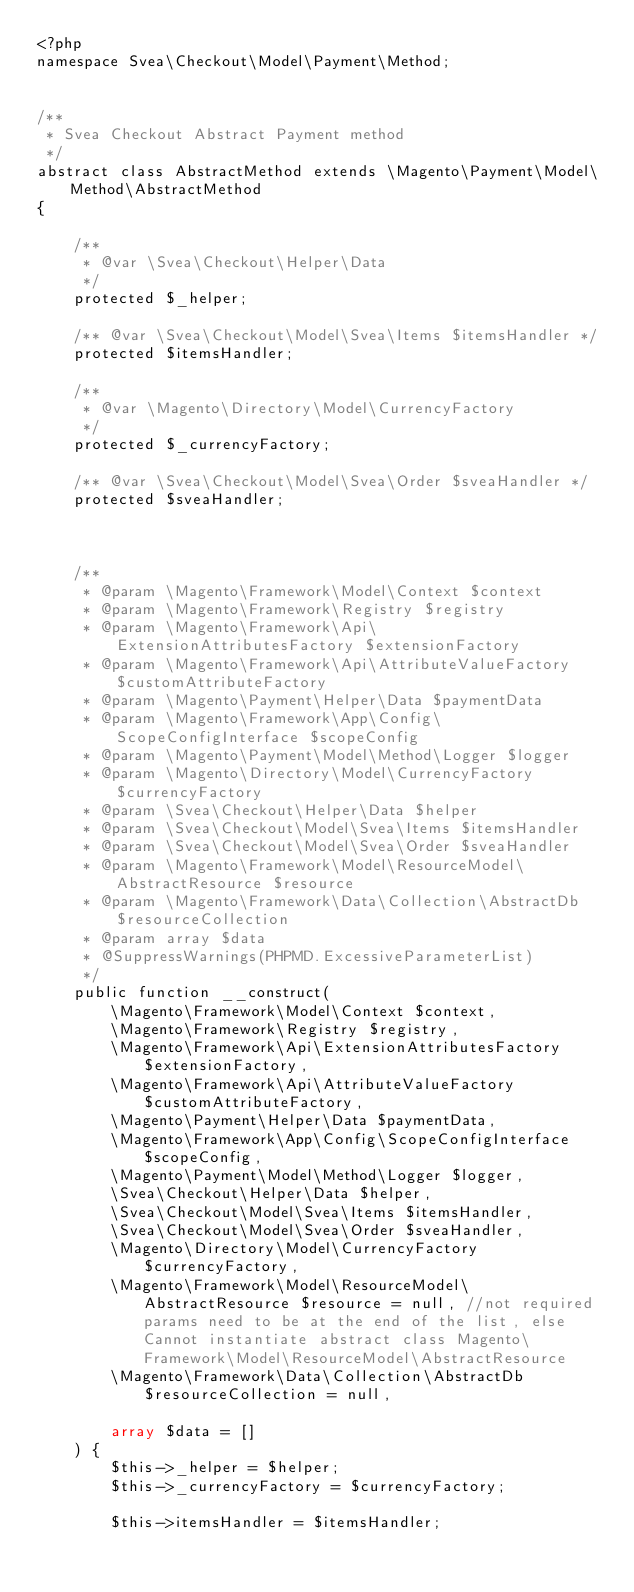Convert code to text. <code><loc_0><loc_0><loc_500><loc_500><_PHP_><?php
namespace Svea\Checkout\Model\Payment\Method;


/**
 * Svea Checkout Abstract Payment method
 */
abstract class AbstractMethod extends \Magento\Payment\Model\Method\AbstractMethod
{

    /**
     * @var \Svea\Checkout\Helper\Data
     */
    protected $_helper;

    /** @var \Svea\Checkout\Model\Svea\Items $itemsHandler */
    protected $itemsHandler;

    /**
     * @var \Magento\Directory\Model\CurrencyFactory
     */
    protected $_currencyFactory;

    /** @var \Svea\Checkout\Model\Svea\Order $sveaHandler */
    protected $sveaHandler;



    /**
     * @param \Magento\Framework\Model\Context $context
     * @param \Magento\Framework\Registry $registry
     * @param \Magento\Framework\Api\ExtensionAttributesFactory $extensionFactory
     * @param \Magento\Framework\Api\AttributeValueFactory $customAttributeFactory
     * @param \Magento\Payment\Helper\Data $paymentData
     * @param \Magento\Framework\App\Config\ScopeConfigInterface $scopeConfig
     * @param \Magento\Payment\Model\Method\Logger $logger
     * @param \Magento\Directory\Model\CurrencyFactory $currencyFactory
     * @param \Svea\Checkout\Helper\Data $helper
     * @param \Svea\Checkout\Model\Svea\Items $itemsHandler
     * @param \Svea\Checkout\Model\Svea\Order $sveaHandler
     * @param \Magento\Framework\Model\ResourceModel\AbstractResource $resource
     * @param \Magento\Framework\Data\Collection\AbstractDb $resourceCollection
     * @param array $data
     * @SuppressWarnings(PHPMD.ExcessiveParameterList)
     */
    public function __construct(
        \Magento\Framework\Model\Context $context,
        \Magento\Framework\Registry $registry,
        \Magento\Framework\Api\ExtensionAttributesFactory $extensionFactory,
        \Magento\Framework\Api\AttributeValueFactory $customAttributeFactory,
        \Magento\Payment\Helper\Data $paymentData,
        \Magento\Framework\App\Config\ScopeConfigInterface $scopeConfig,
        \Magento\Payment\Model\Method\Logger $logger,
        \Svea\Checkout\Helper\Data $helper,
        \Svea\Checkout\Model\Svea\Items $itemsHandler,
        \Svea\Checkout\Model\Svea\Order $sveaHandler,
        \Magento\Directory\Model\CurrencyFactory $currencyFactory,
        \Magento\Framework\Model\ResourceModel\AbstractResource $resource = null, //not required params need to be at the end of the list, else Cannot instantiate abstract class Magento\Framework\Model\ResourceModel\AbstractResource
        \Magento\Framework\Data\Collection\AbstractDb $resourceCollection = null,

        array $data = []
    ) {
        $this->_helper = $helper;
        $this->_currencyFactory = $currencyFactory;

        $this->itemsHandler = $itemsHandler;</code> 